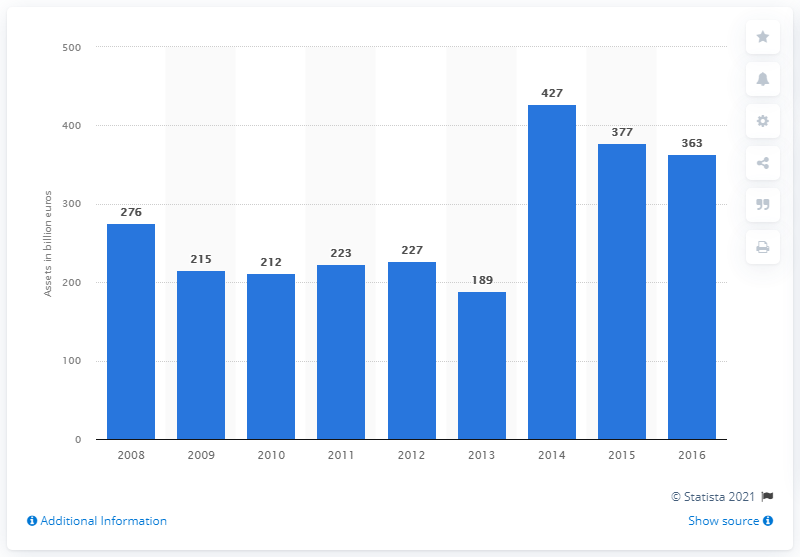Outline some significant characteristics in this image. In 2016, the assets of foreign-controlled banking group subsidiaries and branches in France were valued at approximately 363 billion U.S. dollars. 